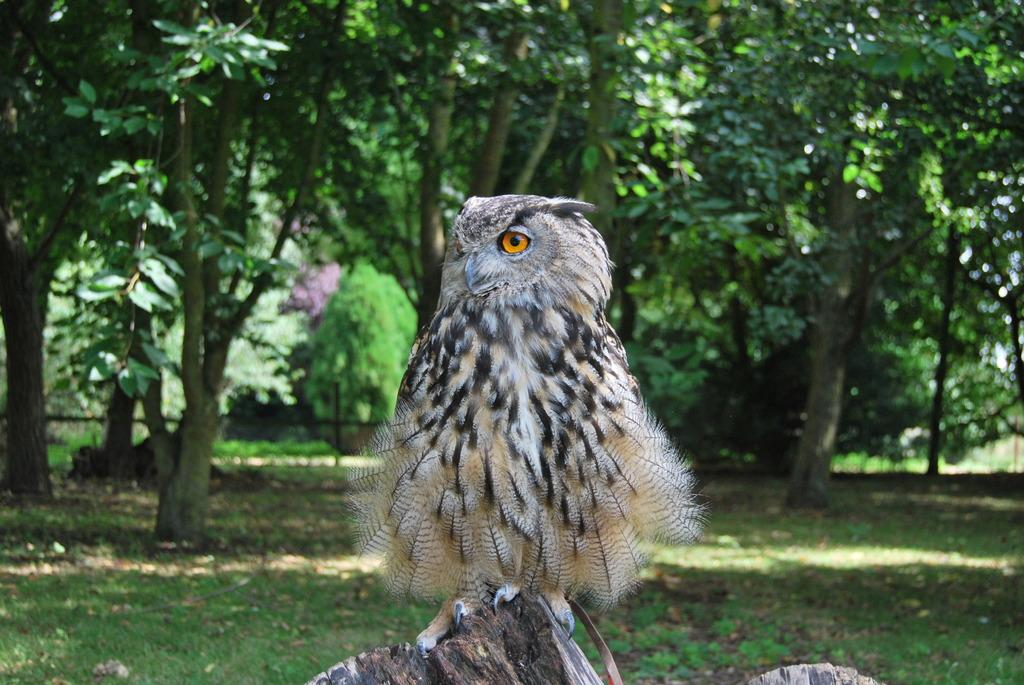What animal is the main subject of the picture? There is an owl in the picture. What is the owl standing on? The owl is standing on wood. What can be seen in the background of the picture? There are plants and trees in the background of the picture. What type of test is the owl administering to the hen in the picture? There is no hen present in the image, and the owl is not administering any test. 